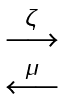<formula> <loc_0><loc_0><loc_500><loc_500>\begin{matrix} \stackrel { \zeta } { \longrightarrow } \\ \stackrel { \mu } { \longleftarrow } \end{matrix}</formula> 